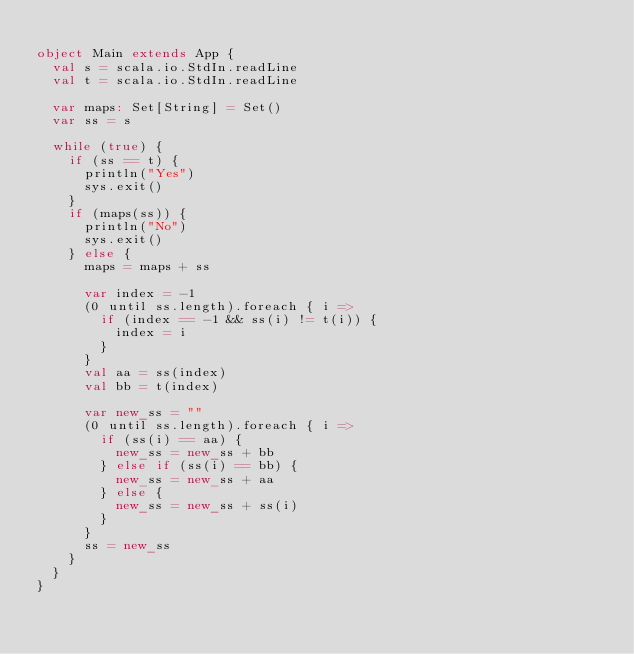Convert code to text. <code><loc_0><loc_0><loc_500><loc_500><_Scala_>
object Main extends App {
  val s = scala.io.StdIn.readLine
  val t = scala.io.StdIn.readLine

  var maps: Set[String] = Set()
  var ss = s

  while (true) {
    if (ss == t) {
      println("Yes")
      sys.exit()
    }
    if (maps(ss)) {
      println("No")
      sys.exit()
    } else {
      maps = maps + ss

      var index = -1
      (0 until ss.length).foreach { i =>
        if (index == -1 && ss(i) != t(i)) {
          index = i
        }
      }
      val aa = ss(index)
      val bb = t(index)

      var new_ss = ""
      (0 until ss.length).foreach { i =>
        if (ss(i) == aa) {
          new_ss = new_ss + bb
        } else if (ss(i) == bb) {
          new_ss = new_ss + aa
        } else {
          new_ss = new_ss + ss(i)
        }
      }
      ss = new_ss
    }
  }
}
</code> 